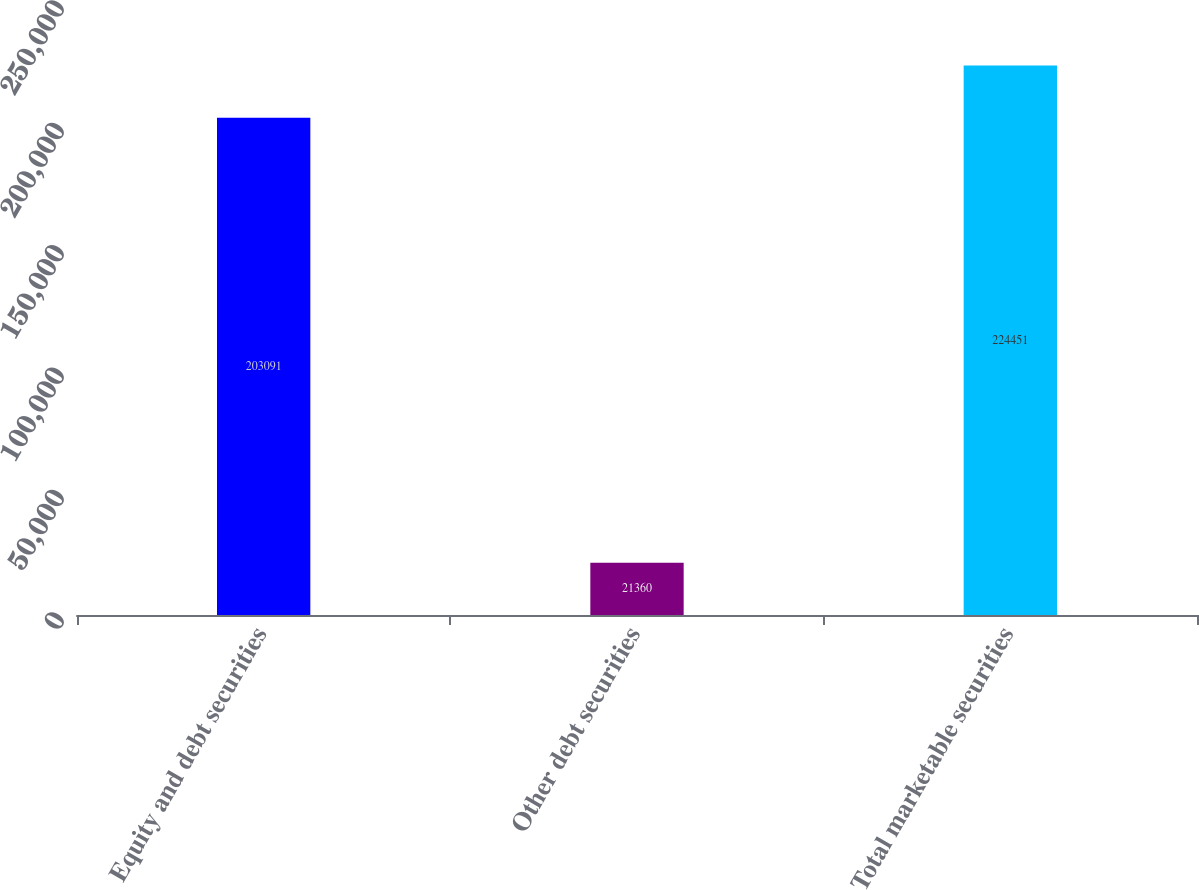Convert chart. <chart><loc_0><loc_0><loc_500><loc_500><bar_chart><fcel>Equity and debt securities<fcel>Other debt securities<fcel>Total marketable securities<nl><fcel>203091<fcel>21360<fcel>224451<nl></chart> 